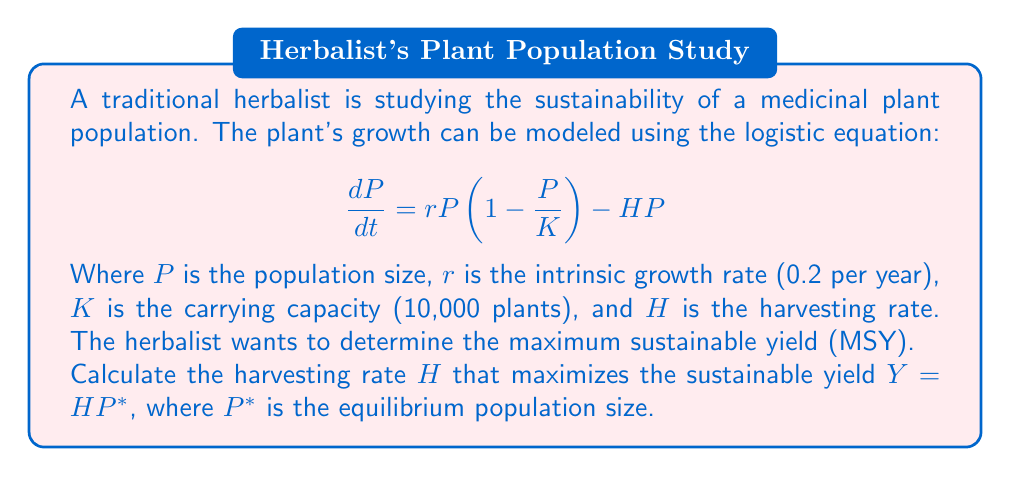What is the answer to this math problem? To solve this problem, we'll follow these steps:

1) First, we need to find the equilibrium population size $P^*$. At equilibrium, $\frac{dP}{dt} = 0$, so:

   $$0 = rP^*(1 - \frac{P^*}{K}) - HP^*$$

2) Solving for $P^*$:

   $$rP^*(1 - \frac{P^*}{K}) = HP^*$$
   $$r(1 - \frac{P^*}{K}) = H$$
   $$r - \frac{rP^*}{K} = H$$
   $$P^* = K(1 - \frac{H}{r})$$

3) The yield $Y$ is given by $Y = HP^*$. Substituting our expression for $P^*$:

   $$Y = HK(1 - \frac{H}{r})$$

4) To find the maximum of this function, we differentiate with respect to $H$ and set it to zero:

   $$\frac{dY}{dH} = K(1 - \frac{H}{r}) - \frac{HK}{r} = 0$$

5) Solving this equation:

   $$K - \frac{KH}{r} - \frac{KH}{r} = 0$$
   $$K - \frac{2KH}{r} = 0$$
   $$1 - \frac{2H}{r} = 0$$
   $$\frac{2H}{r} = 1$$
   $$H = \frac{r}{2}$$

6) Therefore, the maximum sustainable yield occurs when $H = \frac{r}{2} = 0.1$ per year.

7) We can verify this is a maximum by checking the second derivative is negative at this point.

8) The equilibrium population size at this harvesting rate is:

   $$P^* = K(1 - \frac{H}{r}) = 10,000(1 - \frac{0.1}{0.2}) = 5,000$$ plants

9) The maximum sustainable yield is thus:

   $$Y = HP^* = 0.1 * 5,000 = 500$$ plants per year
Answer: The harvesting rate that maximizes the sustainable yield is $H = 0.1$ per year, resulting in a maximum sustainable yield of 500 plants per year. 